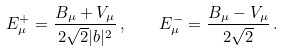<formula> <loc_0><loc_0><loc_500><loc_500>E ^ { + } _ { \mu } = \frac { B _ { \mu } + V _ { \mu } } { 2 \sqrt { 2 } | b | ^ { 2 } } \, , \quad E ^ { - } _ { \mu } = \frac { B _ { \mu } - V _ { \mu } } { 2 \sqrt { 2 } } \, .</formula> 